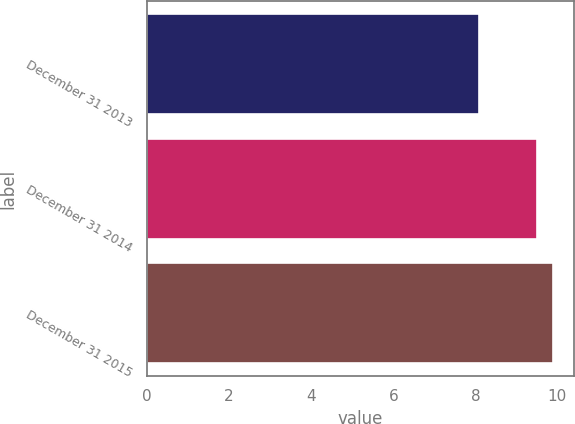<chart> <loc_0><loc_0><loc_500><loc_500><bar_chart><fcel>December 31 2013<fcel>December 31 2014<fcel>December 31 2015<nl><fcel>8.1<fcel>9.5<fcel>9.9<nl></chart> 